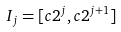Convert formula to latex. <formula><loc_0><loc_0><loc_500><loc_500>I _ { j } = [ c 2 ^ { j } , c 2 ^ { j + 1 } ]</formula> 